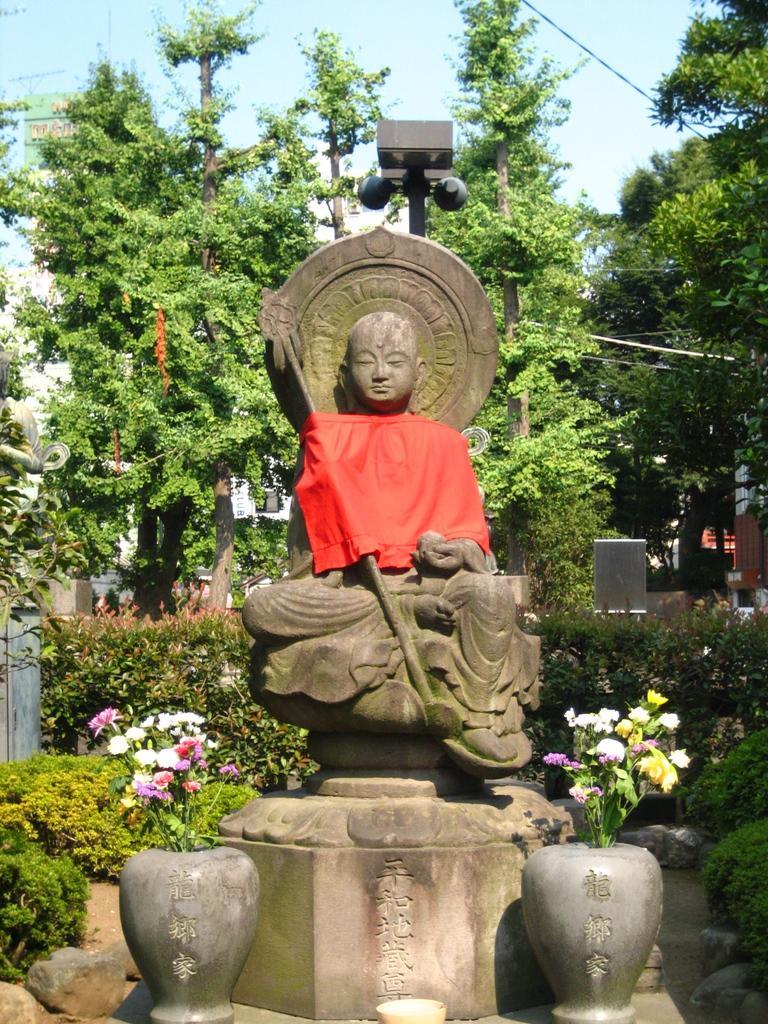Could you give a brief overview of what you see in this image? In this image, we can see some flower vases in front of the statue. In the background of the image, we can see some plants and trees. There is a sky at the top of the image. 